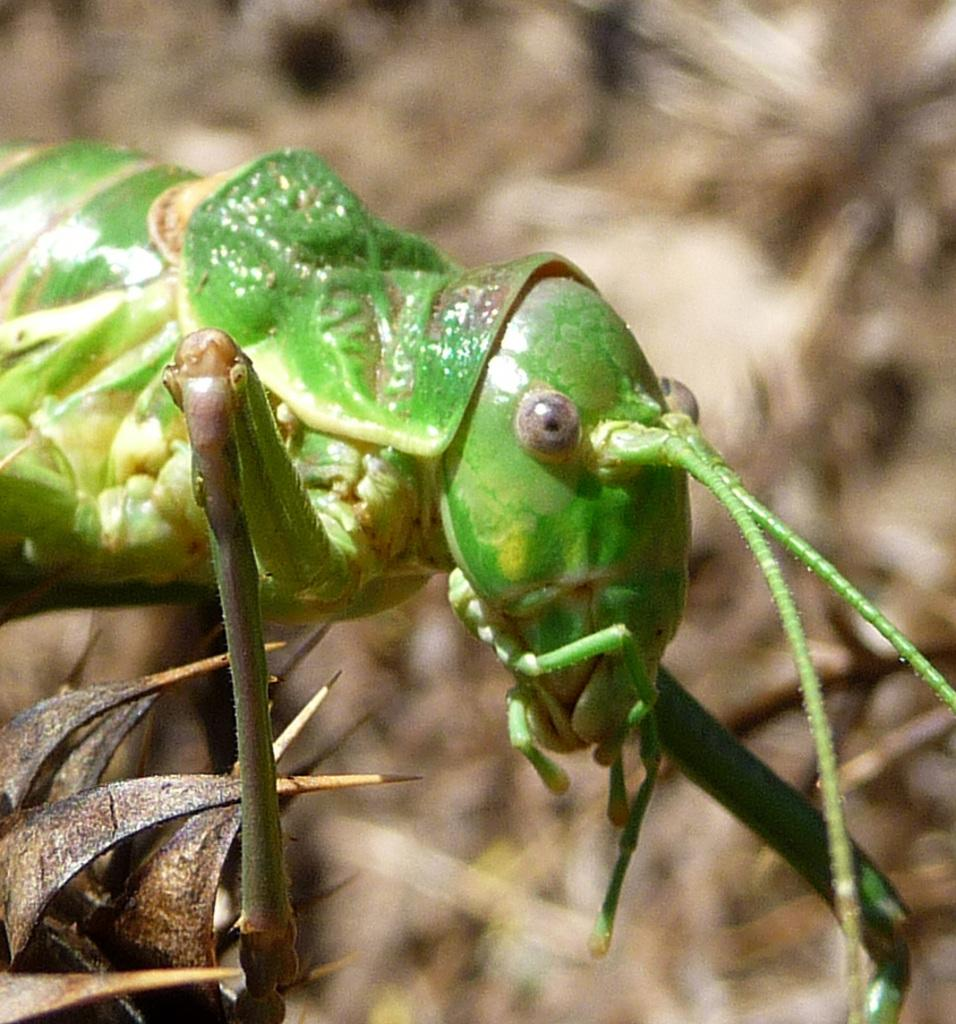What type of creature is present in the image? There is an insect in the image. What color is the insect? The insect is green in color. What can be seen at the bottom of the image? There are dried leaves at the bottom of the image. How would you describe the background of the image? The background of the image is blurred. What condition is the rake in, as seen in the image? There is no rake present in the image. How far away is the insect from the camera in the image? The distance between the insect and the camera cannot be determined from the image alone. 